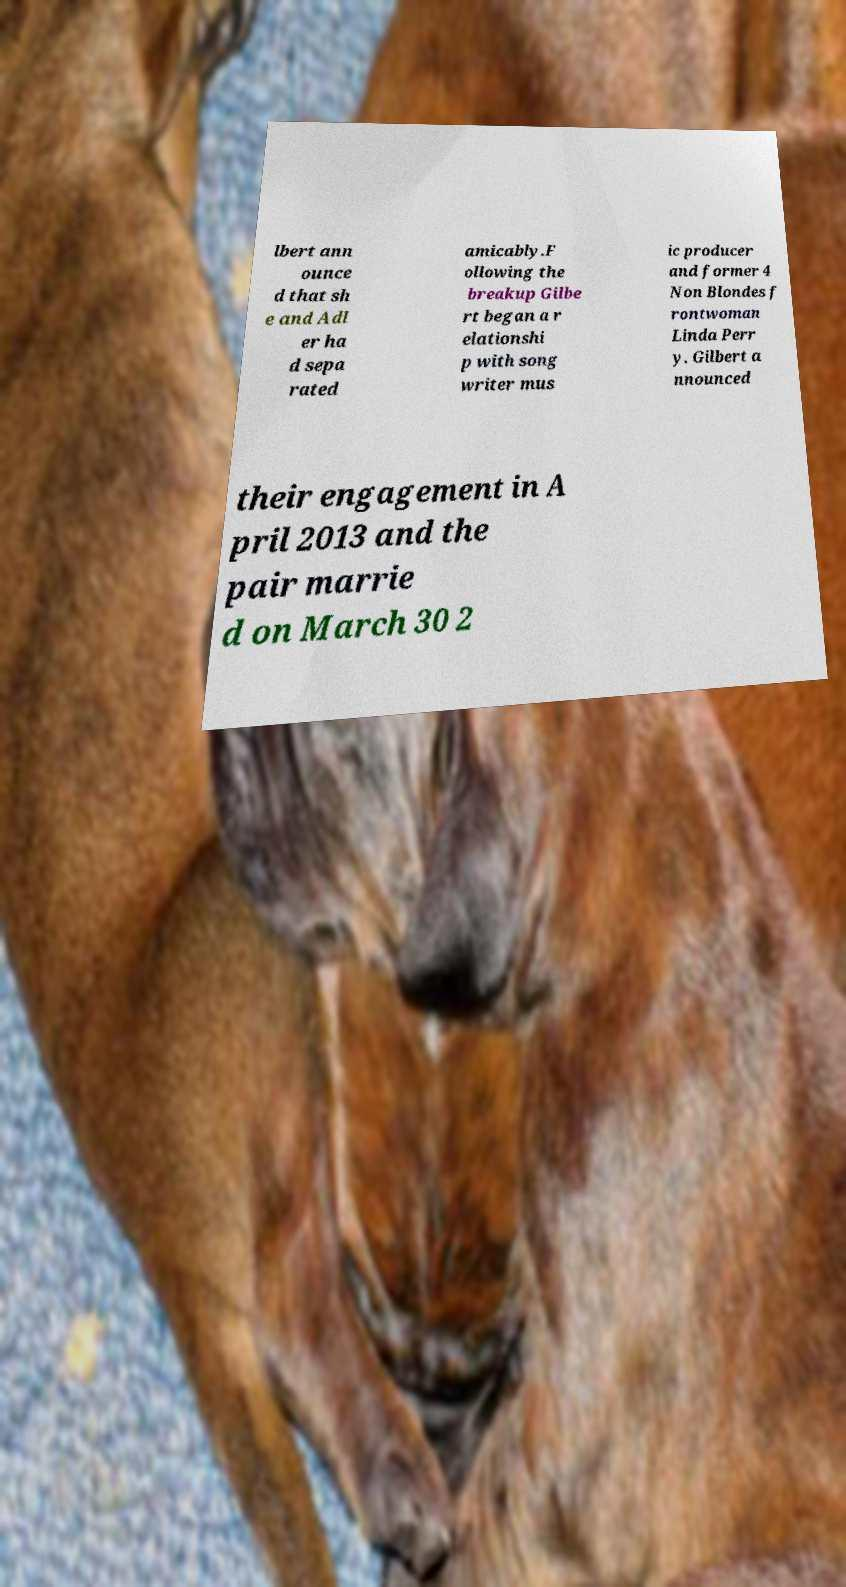Can you read and provide the text displayed in the image?This photo seems to have some interesting text. Can you extract and type it out for me? lbert ann ounce d that sh e and Adl er ha d sepa rated amicably.F ollowing the breakup Gilbe rt began a r elationshi p with song writer mus ic producer and former 4 Non Blondes f rontwoman Linda Perr y. Gilbert a nnounced their engagement in A pril 2013 and the pair marrie d on March 30 2 